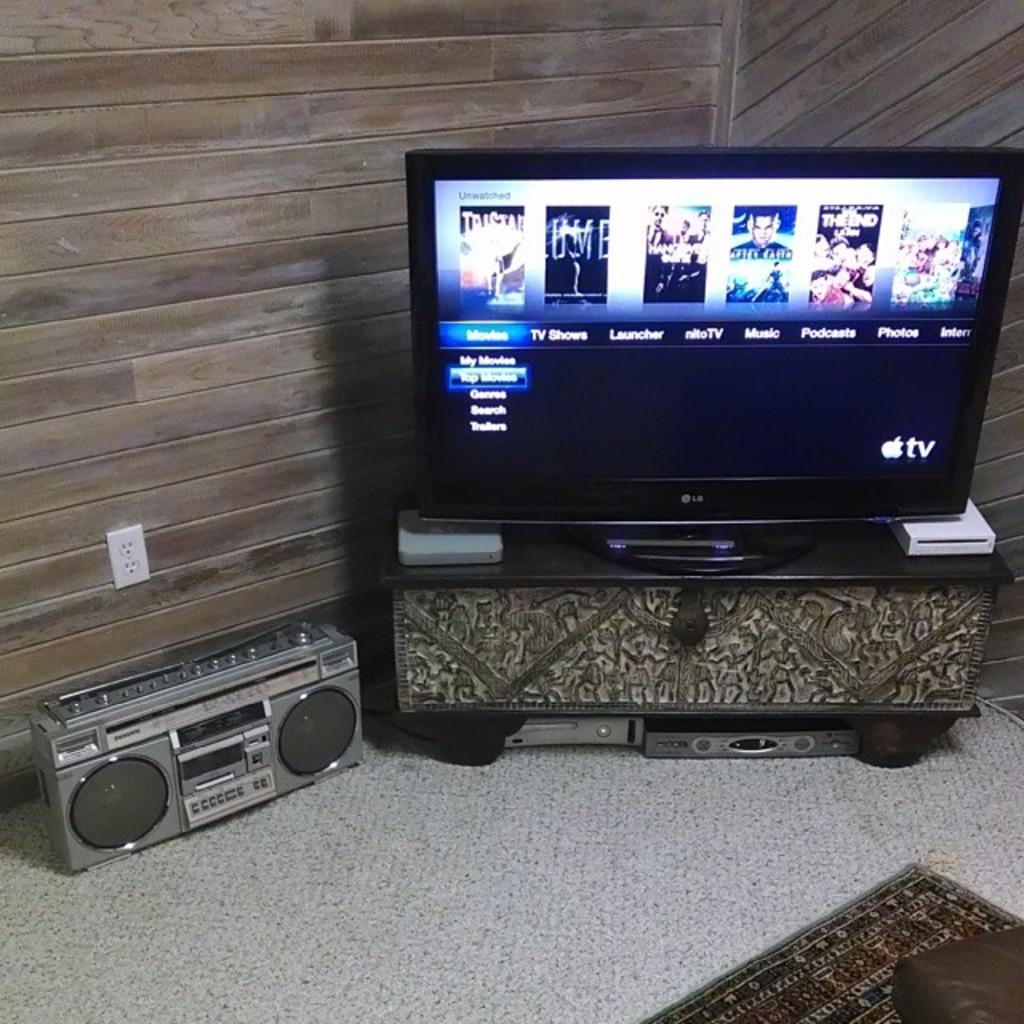What streaming service is this?
Provide a succinct answer. Apple tv. 